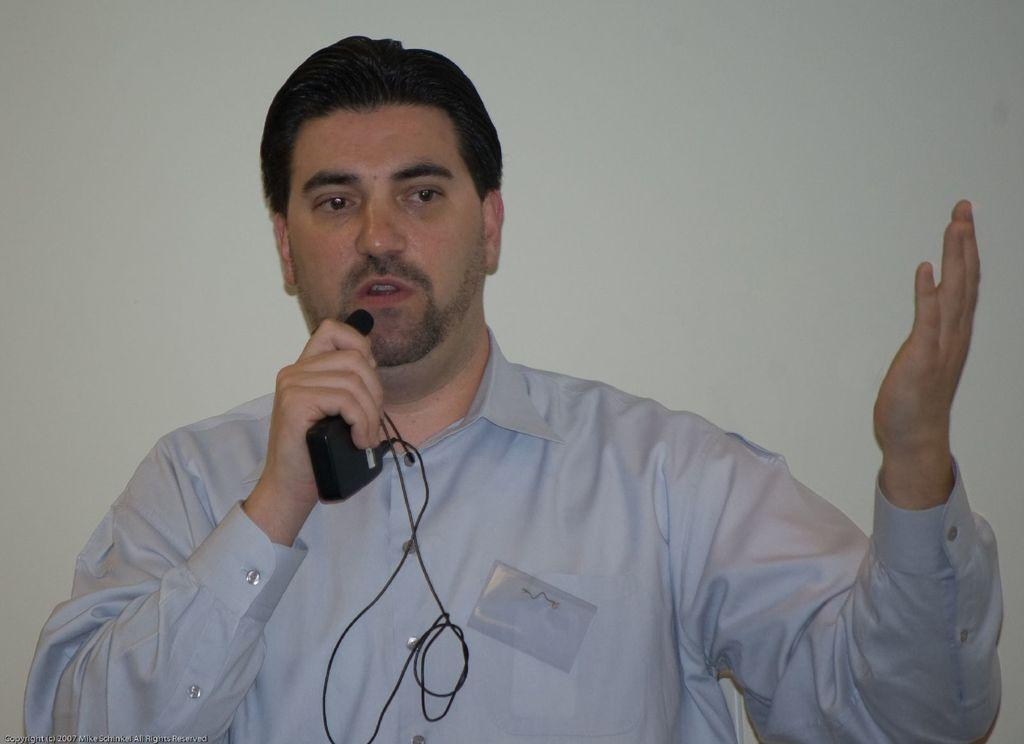Who is the main subject in the image? There is a man in the image. What is the man wearing? The man is wearing a white color shirt. What is the man holding in his hand? The man is holding a microphone in his hand. What is the man doing with the microphone? The man is speaking into the microphone. What can be seen in the background of the image? There is a wall in the background of the image. What type of force can be seen pushing the drawer in the image? There is no drawer present in the image, so no force can be seen pushing a drawer. What color is the sky in the image? The provided facts do not mention the sky, so we cannot determine its color from the image. 